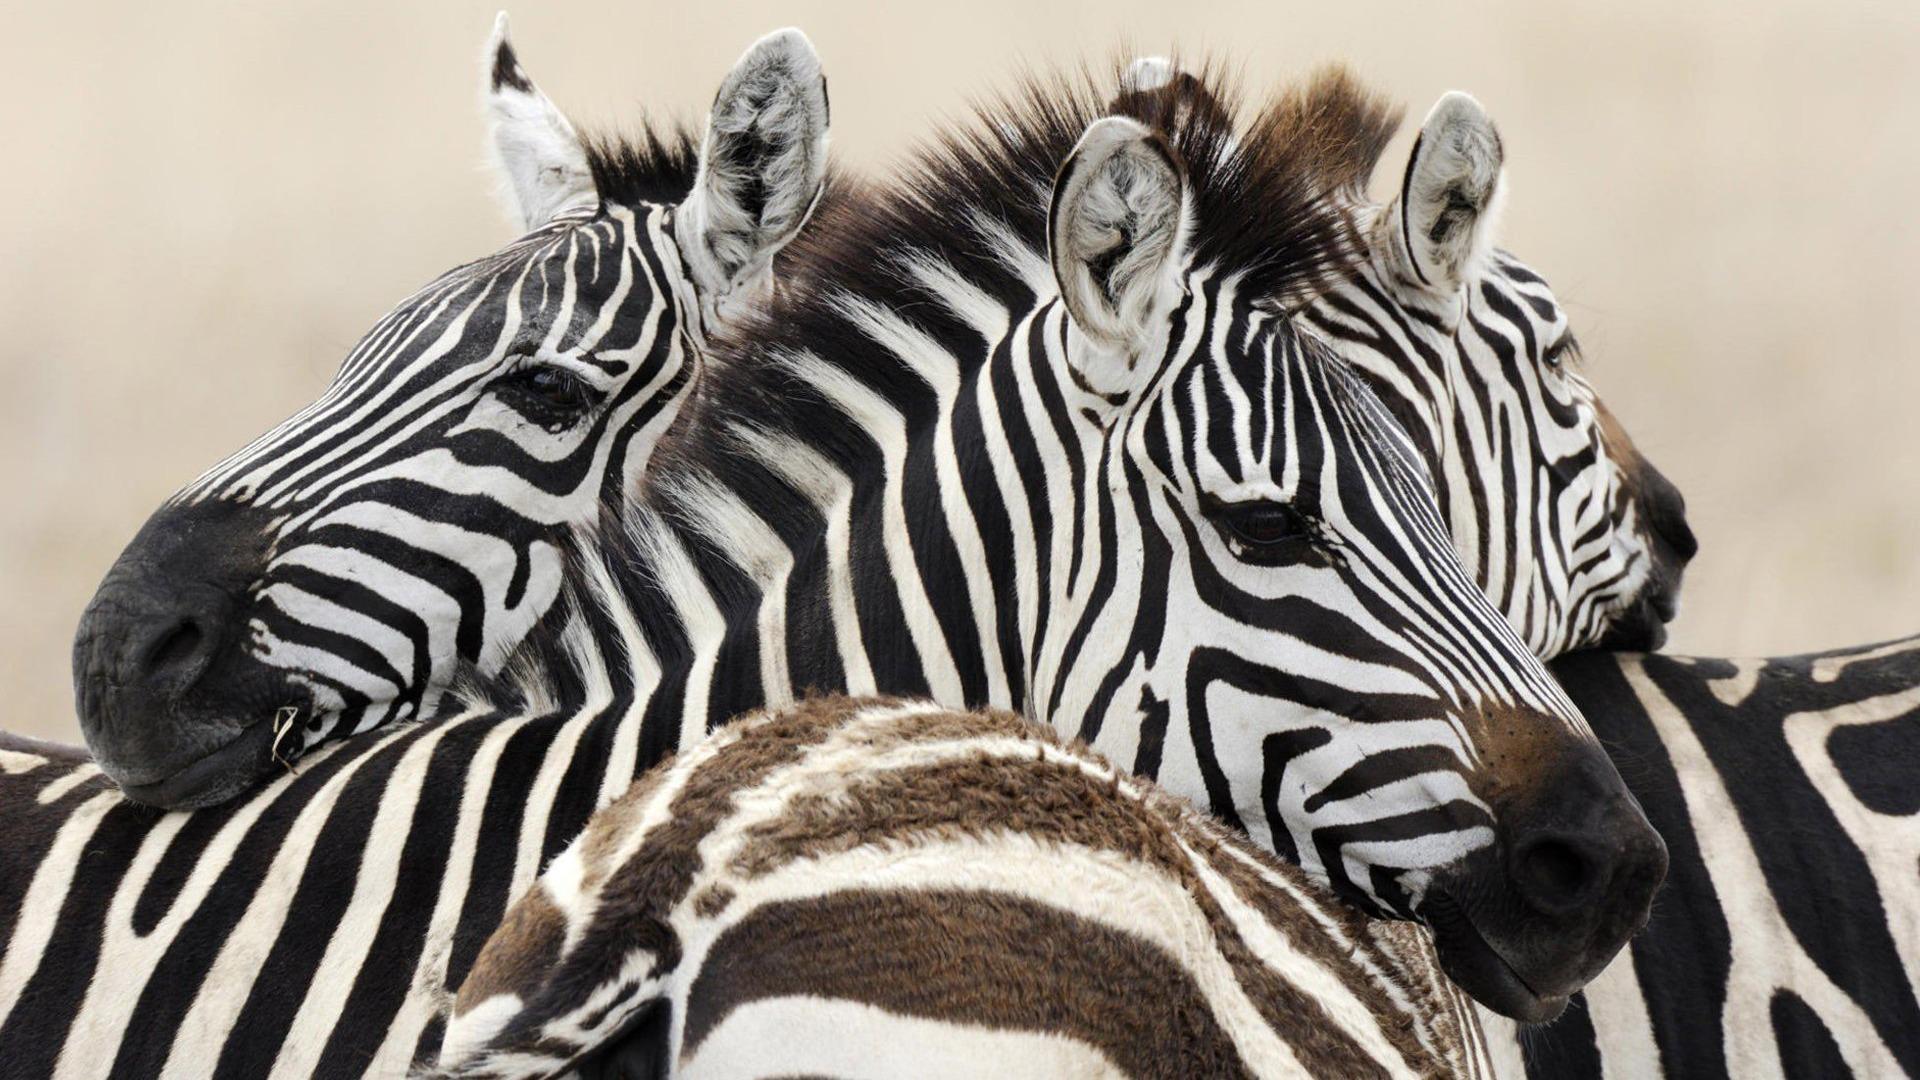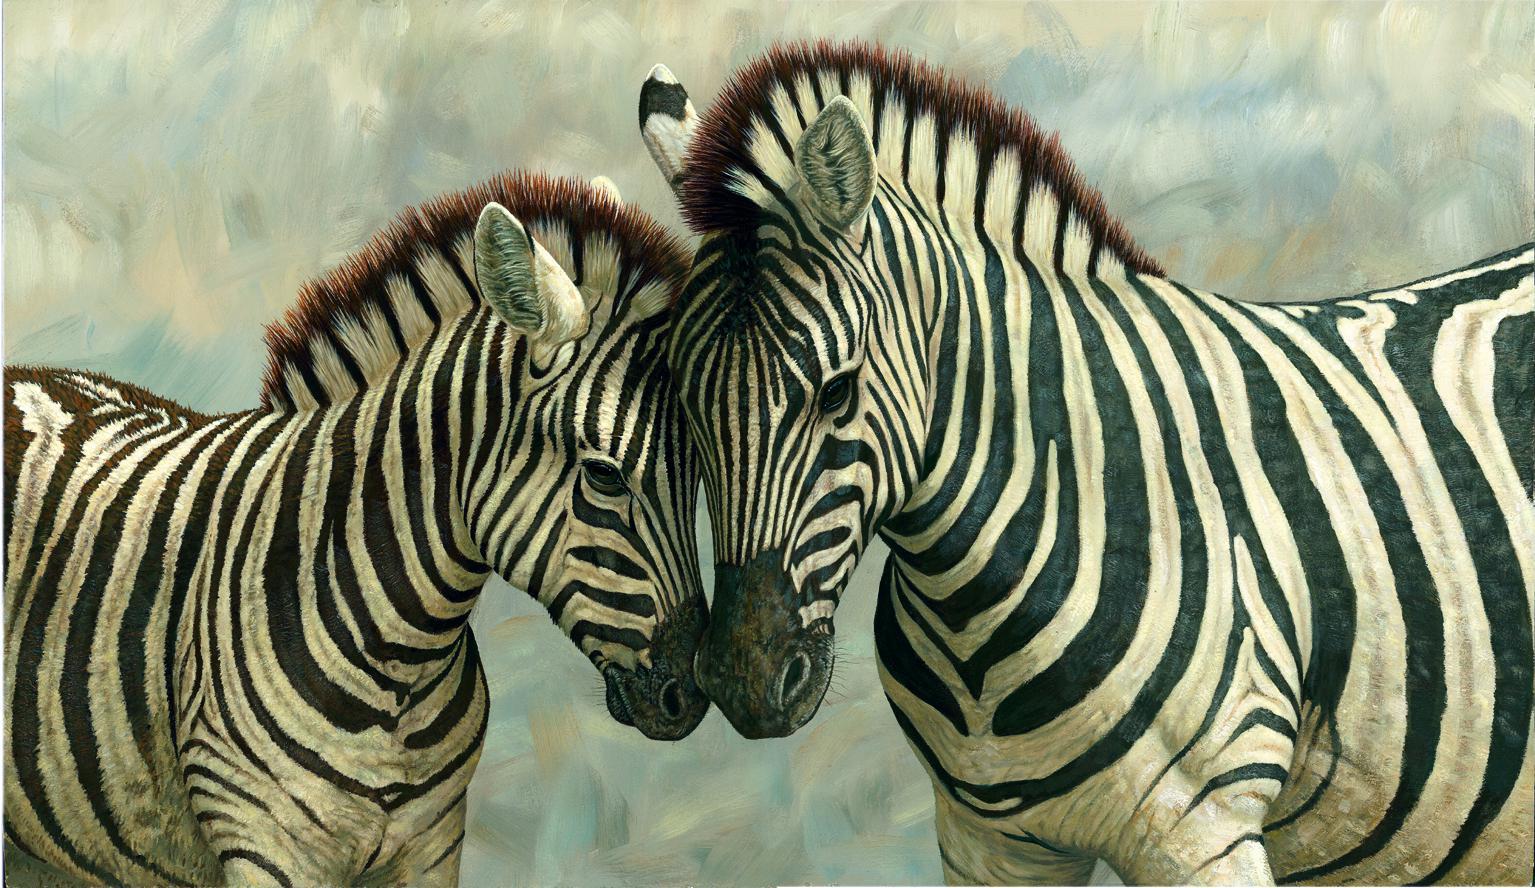The first image is the image on the left, the second image is the image on the right. Assess this claim about the two images: "At least three zebras in each image are facing the same direction.". Correct or not? Answer yes or no. No. The first image is the image on the left, the second image is the image on the right. Considering the images on both sides, is "Neither image in the pair shows fewer than three zebras." valid? Answer yes or no. No. 